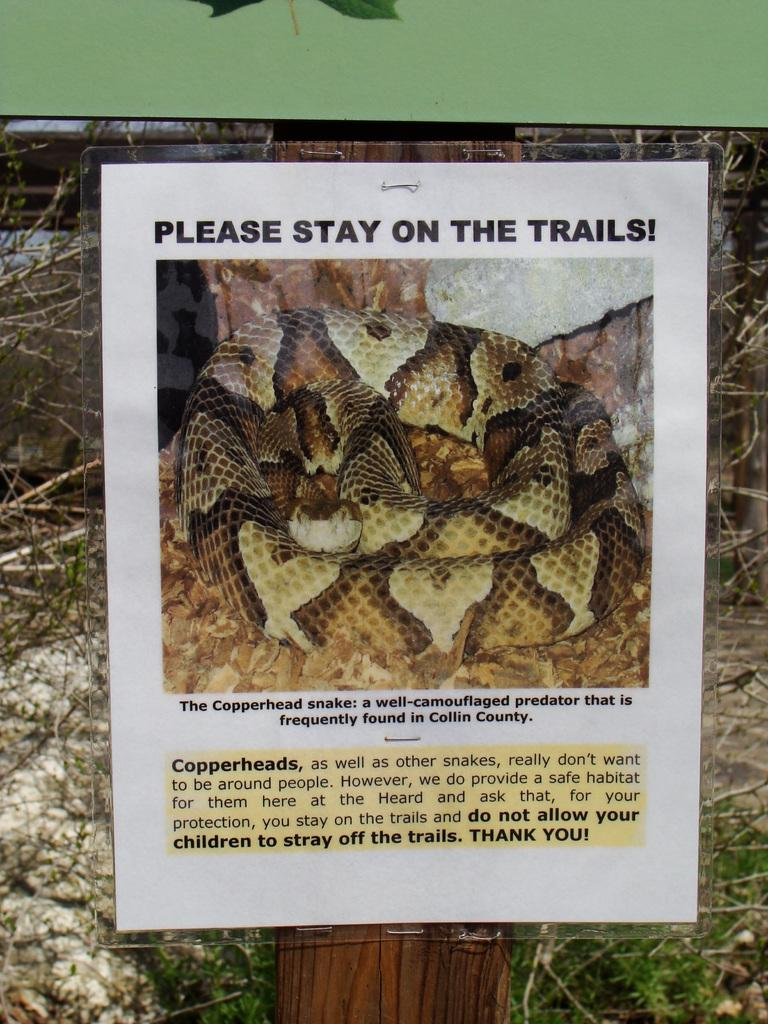What is the main subject of the image? There is a photo in the image. What is depicted in the photo? The photo contains a snake. Are there any words or letters in the photo? Yes, there is text in the photo. How does the snake say good-bye to the other animals in the image? There are no other animals present in the image, and snakes do not have the ability to say good-bye. 